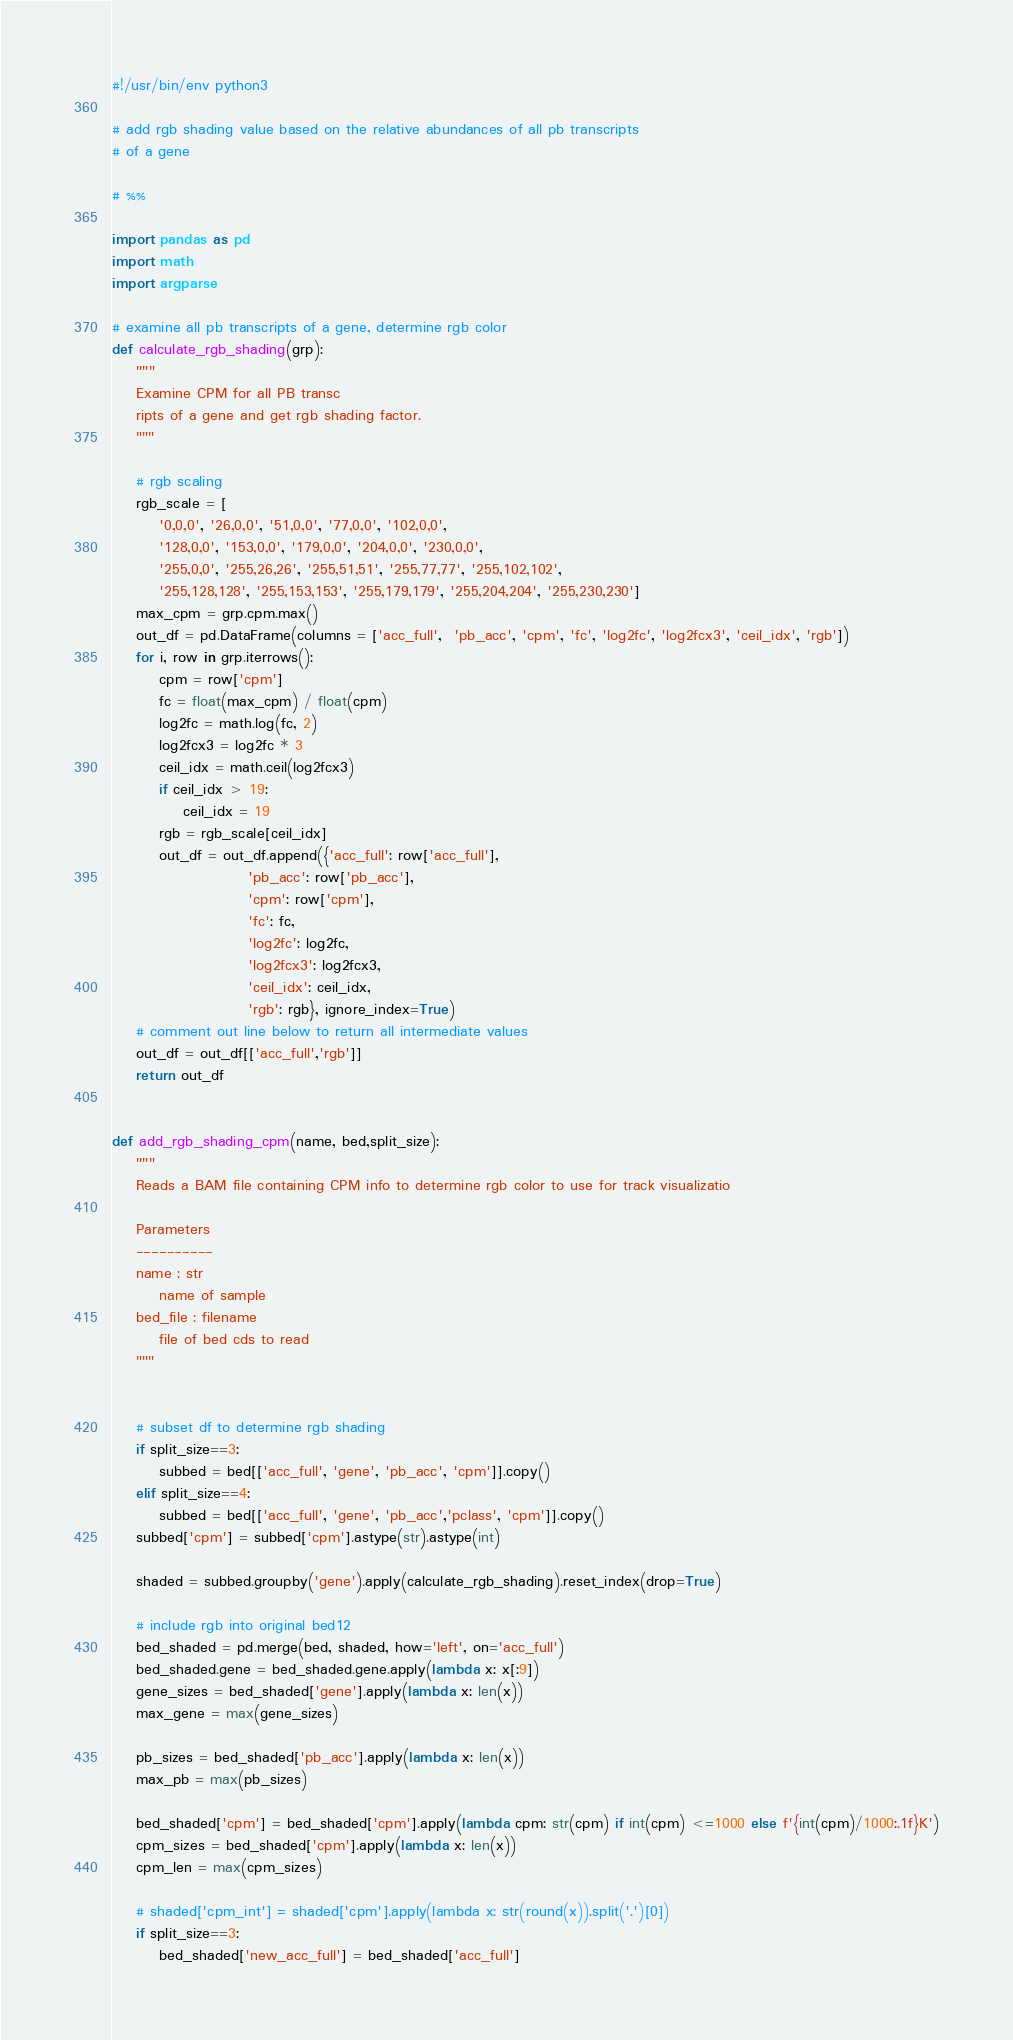Convert code to text. <code><loc_0><loc_0><loc_500><loc_500><_Python_>#!/usr/bin/env python3

# add rgb shading value based on the relative abundances of all pb transcripts
# of a gene

# %%

import pandas as pd
import math
import argparse

# examine all pb transcripts of a gene, determine rgb color
def calculate_rgb_shading(grp):
    """
    Examine CPM for all PB transc
    ripts of a gene and get rgb shading factor.
    """

    # rgb scaling
    rgb_scale = [
        '0,0,0', '26,0,0', '51,0,0', '77,0,0', '102,0,0',
        '128,0,0', '153,0,0', '179,0,0', '204,0,0', '230,0,0',
        '255,0,0', '255,26,26', '255,51,51', '255,77,77', '255,102,102',
        '255,128,128', '255,153,153', '255,179,179', '255,204,204', '255,230,230']
    max_cpm = grp.cpm.max()
    out_df = pd.DataFrame(columns = ['acc_full',  'pb_acc', 'cpm', 'fc', 'log2fc', 'log2fcx3', 'ceil_idx', 'rgb'])
    for i, row in grp.iterrows():
        cpm = row['cpm']
        fc = float(max_cpm) / float(cpm)
        log2fc = math.log(fc, 2) 
        log2fcx3 = log2fc * 3
        ceil_idx = math.ceil(log2fcx3)
        if ceil_idx > 19:
            ceil_idx = 19
        rgb = rgb_scale[ceil_idx] 
        out_df = out_df.append({'acc_full': row['acc_full'],
                       'pb_acc': row['pb_acc'],
                       'cpm': row['cpm'],
                       'fc': fc,
                       'log2fc': log2fc,
                       'log2fcx3': log2fcx3,
                       'ceil_idx': ceil_idx,
                       'rgb': rgb}, ignore_index=True)
    # comment out line below to return all intermediate values
    out_df = out_df[['acc_full','rgb']]
    return out_df


def add_rgb_shading_cpm(name, bed,split_size):
    """
    Reads a BAM file containing CPM info to determine rgb color to use for track visualizatio

    Parameters
    ----------
    name : str 
        name of sample
    bed_file : filename
        file of bed cds to read
    """
    
    
    # subset df to determine rgb shading
    if split_size==3:
        subbed = bed[['acc_full', 'gene', 'pb_acc', 'cpm']].copy()
    elif split_size==4:
        subbed = bed[['acc_full', 'gene', 'pb_acc','pclass', 'cpm']].copy()
    subbed['cpm'] = subbed['cpm'].astype(str).astype(int)

    shaded = subbed.groupby('gene').apply(calculate_rgb_shading).reset_index(drop=True)

    # include rgb into original bed12
    bed_shaded = pd.merge(bed, shaded, how='left', on='acc_full')
    bed_shaded.gene = bed_shaded.gene.apply(lambda x: x[:9])
    gene_sizes = bed_shaded['gene'].apply(lambda x: len(x))
    max_gene = max(gene_sizes)

    pb_sizes = bed_shaded['pb_acc'].apply(lambda x: len(x))
    max_pb = max(pb_sizes)

    bed_shaded['cpm'] = bed_shaded['cpm'].apply(lambda cpm: str(cpm) if int(cpm) <=1000 else f'{int(cpm)/1000:.1f}K')
    cpm_sizes = bed_shaded['cpm'].apply(lambda x: len(x))
    cpm_len = max(cpm_sizes)
    
    # shaded['cpm_int'] = shaded['cpm'].apply(lambda x: str(round(x)).split('.')[0])
    if split_size==3:
        bed_shaded['new_acc_full'] = bed_shaded['acc_full']</code> 